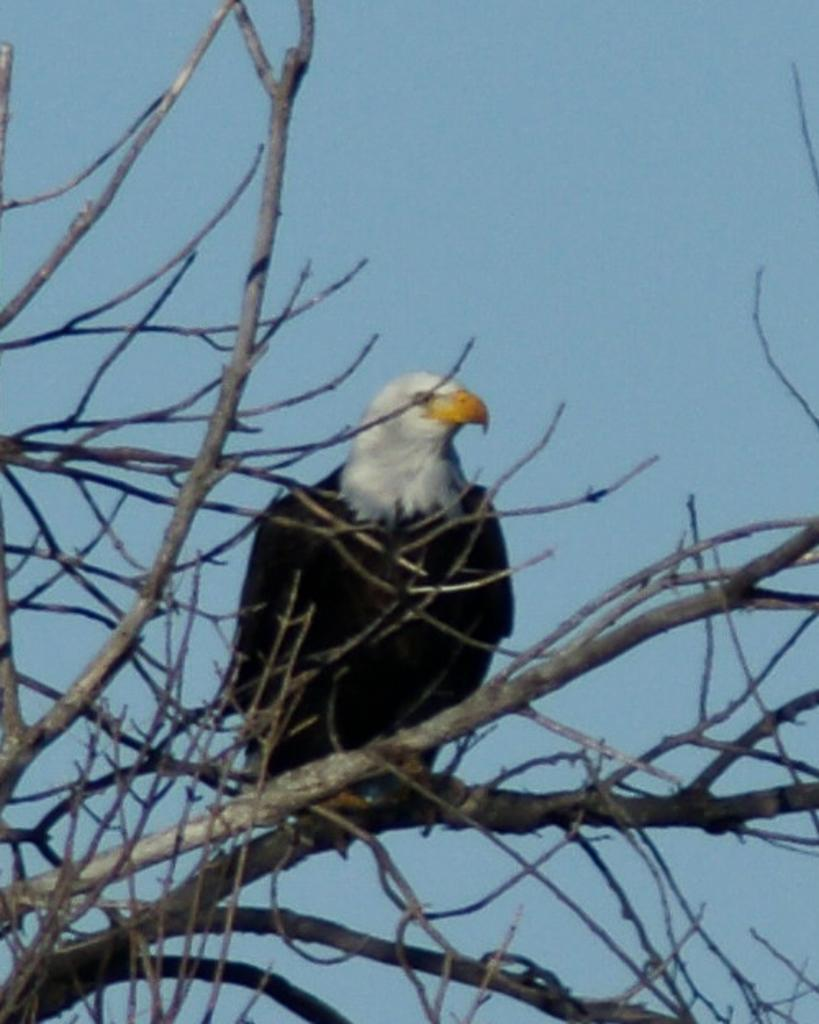What type of bird can be seen in the image? There is a black color bird in the image. What is the bird standing on? The bird is standing on a dry tree. What is visible at the top of the image? The sky is visible at the top of the image. What is the weight of the bird's aunt in the image? There is no mention of an aunt or weight in the image, as it only features a black color bird standing on a dry tree. 